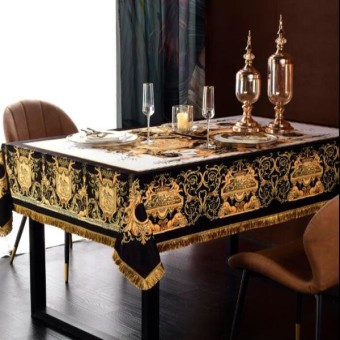How many diningtables are there in the image? 1 